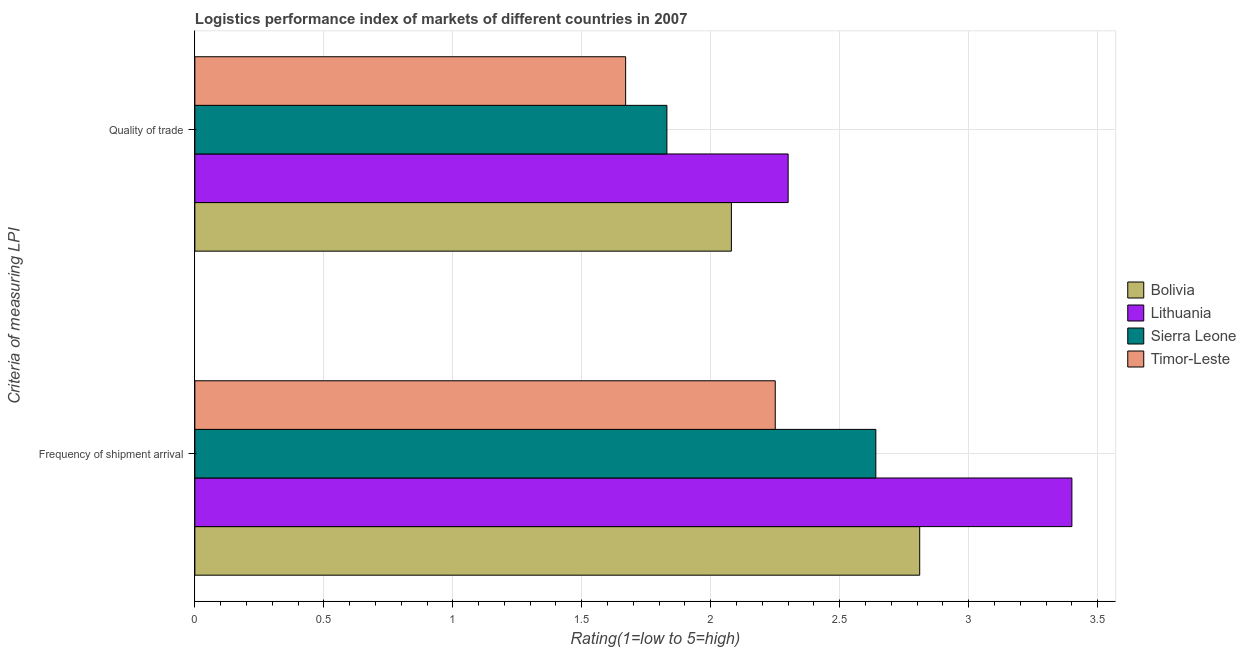How many different coloured bars are there?
Ensure brevity in your answer.  4. How many groups of bars are there?
Ensure brevity in your answer.  2. Are the number of bars per tick equal to the number of legend labels?
Offer a terse response. Yes. Are the number of bars on each tick of the Y-axis equal?
Provide a succinct answer. Yes. What is the label of the 2nd group of bars from the top?
Your answer should be very brief. Frequency of shipment arrival. What is the lpi quality of trade in Bolivia?
Keep it short and to the point. 2.08. Across all countries, what is the maximum lpi of frequency of shipment arrival?
Offer a very short reply. 3.4. Across all countries, what is the minimum lpi of frequency of shipment arrival?
Make the answer very short. 2.25. In which country was the lpi of frequency of shipment arrival maximum?
Offer a terse response. Lithuania. In which country was the lpi quality of trade minimum?
Provide a short and direct response. Timor-Leste. What is the total lpi of frequency of shipment arrival in the graph?
Give a very brief answer. 11.1. What is the difference between the lpi of frequency of shipment arrival in Timor-Leste and that in Sierra Leone?
Offer a terse response. -0.39. What is the difference between the lpi of frequency of shipment arrival in Bolivia and the lpi quality of trade in Lithuania?
Ensure brevity in your answer.  0.51. What is the average lpi quality of trade per country?
Your answer should be very brief. 1.97. What is the difference between the lpi quality of trade and lpi of frequency of shipment arrival in Bolivia?
Provide a short and direct response. -0.73. In how many countries, is the lpi quality of trade greater than 2.7 ?
Offer a terse response. 0. What is the ratio of the lpi quality of trade in Timor-Leste to that in Sierra Leone?
Ensure brevity in your answer.  0.91. In how many countries, is the lpi quality of trade greater than the average lpi quality of trade taken over all countries?
Keep it short and to the point. 2. What does the 3rd bar from the top in Frequency of shipment arrival represents?
Ensure brevity in your answer.  Lithuania. What does the 2nd bar from the bottom in Quality of trade represents?
Ensure brevity in your answer.  Lithuania. Are all the bars in the graph horizontal?
Provide a succinct answer. Yes. Does the graph contain any zero values?
Give a very brief answer. No. Does the graph contain grids?
Your answer should be very brief. Yes. How many legend labels are there?
Offer a terse response. 4. What is the title of the graph?
Offer a terse response. Logistics performance index of markets of different countries in 2007. What is the label or title of the X-axis?
Ensure brevity in your answer.  Rating(1=low to 5=high). What is the label or title of the Y-axis?
Make the answer very short. Criteria of measuring LPI. What is the Rating(1=low to 5=high) in Bolivia in Frequency of shipment arrival?
Provide a succinct answer. 2.81. What is the Rating(1=low to 5=high) of Lithuania in Frequency of shipment arrival?
Offer a very short reply. 3.4. What is the Rating(1=low to 5=high) in Sierra Leone in Frequency of shipment arrival?
Provide a short and direct response. 2.64. What is the Rating(1=low to 5=high) of Timor-Leste in Frequency of shipment arrival?
Provide a succinct answer. 2.25. What is the Rating(1=low to 5=high) in Bolivia in Quality of trade?
Your answer should be very brief. 2.08. What is the Rating(1=low to 5=high) in Lithuania in Quality of trade?
Make the answer very short. 2.3. What is the Rating(1=low to 5=high) in Sierra Leone in Quality of trade?
Keep it short and to the point. 1.83. What is the Rating(1=low to 5=high) in Timor-Leste in Quality of trade?
Give a very brief answer. 1.67. Across all Criteria of measuring LPI, what is the maximum Rating(1=low to 5=high) of Bolivia?
Offer a terse response. 2.81. Across all Criteria of measuring LPI, what is the maximum Rating(1=low to 5=high) of Sierra Leone?
Your answer should be compact. 2.64. Across all Criteria of measuring LPI, what is the maximum Rating(1=low to 5=high) of Timor-Leste?
Your response must be concise. 2.25. Across all Criteria of measuring LPI, what is the minimum Rating(1=low to 5=high) of Bolivia?
Ensure brevity in your answer.  2.08. Across all Criteria of measuring LPI, what is the minimum Rating(1=low to 5=high) in Lithuania?
Provide a succinct answer. 2.3. Across all Criteria of measuring LPI, what is the minimum Rating(1=low to 5=high) of Sierra Leone?
Offer a terse response. 1.83. Across all Criteria of measuring LPI, what is the minimum Rating(1=low to 5=high) in Timor-Leste?
Make the answer very short. 1.67. What is the total Rating(1=low to 5=high) in Bolivia in the graph?
Your answer should be very brief. 4.89. What is the total Rating(1=low to 5=high) of Lithuania in the graph?
Provide a succinct answer. 5.7. What is the total Rating(1=low to 5=high) of Sierra Leone in the graph?
Provide a succinct answer. 4.47. What is the total Rating(1=low to 5=high) of Timor-Leste in the graph?
Your answer should be very brief. 3.92. What is the difference between the Rating(1=low to 5=high) in Bolivia in Frequency of shipment arrival and that in Quality of trade?
Keep it short and to the point. 0.73. What is the difference between the Rating(1=low to 5=high) in Sierra Leone in Frequency of shipment arrival and that in Quality of trade?
Offer a terse response. 0.81. What is the difference between the Rating(1=low to 5=high) of Timor-Leste in Frequency of shipment arrival and that in Quality of trade?
Your answer should be compact. 0.58. What is the difference between the Rating(1=low to 5=high) of Bolivia in Frequency of shipment arrival and the Rating(1=low to 5=high) of Lithuania in Quality of trade?
Your answer should be very brief. 0.51. What is the difference between the Rating(1=low to 5=high) of Bolivia in Frequency of shipment arrival and the Rating(1=low to 5=high) of Sierra Leone in Quality of trade?
Provide a succinct answer. 0.98. What is the difference between the Rating(1=low to 5=high) in Bolivia in Frequency of shipment arrival and the Rating(1=low to 5=high) in Timor-Leste in Quality of trade?
Give a very brief answer. 1.14. What is the difference between the Rating(1=low to 5=high) of Lithuania in Frequency of shipment arrival and the Rating(1=low to 5=high) of Sierra Leone in Quality of trade?
Provide a succinct answer. 1.57. What is the difference between the Rating(1=low to 5=high) in Lithuania in Frequency of shipment arrival and the Rating(1=low to 5=high) in Timor-Leste in Quality of trade?
Keep it short and to the point. 1.73. What is the average Rating(1=low to 5=high) in Bolivia per Criteria of measuring LPI?
Make the answer very short. 2.44. What is the average Rating(1=low to 5=high) in Lithuania per Criteria of measuring LPI?
Your response must be concise. 2.85. What is the average Rating(1=low to 5=high) of Sierra Leone per Criteria of measuring LPI?
Ensure brevity in your answer.  2.23. What is the average Rating(1=low to 5=high) of Timor-Leste per Criteria of measuring LPI?
Offer a terse response. 1.96. What is the difference between the Rating(1=low to 5=high) of Bolivia and Rating(1=low to 5=high) of Lithuania in Frequency of shipment arrival?
Provide a succinct answer. -0.59. What is the difference between the Rating(1=low to 5=high) of Bolivia and Rating(1=low to 5=high) of Sierra Leone in Frequency of shipment arrival?
Your answer should be very brief. 0.17. What is the difference between the Rating(1=low to 5=high) in Bolivia and Rating(1=low to 5=high) in Timor-Leste in Frequency of shipment arrival?
Give a very brief answer. 0.56. What is the difference between the Rating(1=low to 5=high) in Lithuania and Rating(1=low to 5=high) in Sierra Leone in Frequency of shipment arrival?
Give a very brief answer. 0.76. What is the difference between the Rating(1=low to 5=high) of Lithuania and Rating(1=low to 5=high) of Timor-Leste in Frequency of shipment arrival?
Offer a very short reply. 1.15. What is the difference between the Rating(1=low to 5=high) of Sierra Leone and Rating(1=low to 5=high) of Timor-Leste in Frequency of shipment arrival?
Offer a very short reply. 0.39. What is the difference between the Rating(1=low to 5=high) in Bolivia and Rating(1=low to 5=high) in Lithuania in Quality of trade?
Your response must be concise. -0.22. What is the difference between the Rating(1=low to 5=high) in Bolivia and Rating(1=low to 5=high) in Timor-Leste in Quality of trade?
Your answer should be compact. 0.41. What is the difference between the Rating(1=low to 5=high) in Lithuania and Rating(1=low to 5=high) in Sierra Leone in Quality of trade?
Offer a very short reply. 0.47. What is the difference between the Rating(1=low to 5=high) of Lithuania and Rating(1=low to 5=high) of Timor-Leste in Quality of trade?
Your answer should be very brief. 0.63. What is the difference between the Rating(1=low to 5=high) of Sierra Leone and Rating(1=low to 5=high) of Timor-Leste in Quality of trade?
Ensure brevity in your answer.  0.16. What is the ratio of the Rating(1=low to 5=high) in Bolivia in Frequency of shipment arrival to that in Quality of trade?
Offer a terse response. 1.35. What is the ratio of the Rating(1=low to 5=high) of Lithuania in Frequency of shipment arrival to that in Quality of trade?
Make the answer very short. 1.48. What is the ratio of the Rating(1=low to 5=high) of Sierra Leone in Frequency of shipment arrival to that in Quality of trade?
Offer a terse response. 1.44. What is the ratio of the Rating(1=low to 5=high) in Timor-Leste in Frequency of shipment arrival to that in Quality of trade?
Ensure brevity in your answer.  1.35. What is the difference between the highest and the second highest Rating(1=low to 5=high) of Bolivia?
Offer a very short reply. 0.73. What is the difference between the highest and the second highest Rating(1=low to 5=high) of Lithuania?
Give a very brief answer. 1.1. What is the difference between the highest and the second highest Rating(1=low to 5=high) of Sierra Leone?
Your answer should be compact. 0.81. What is the difference between the highest and the second highest Rating(1=low to 5=high) in Timor-Leste?
Provide a short and direct response. 0.58. What is the difference between the highest and the lowest Rating(1=low to 5=high) of Bolivia?
Offer a very short reply. 0.73. What is the difference between the highest and the lowest Rating(1=low to 5=high) of Sierra Leone?
Keep it short and to the point. 0.81. What is the difference between the highest and the lowest Rating(1=low to 5=high) in Timor-Leste?
Offer a very short reply. 0.58. 